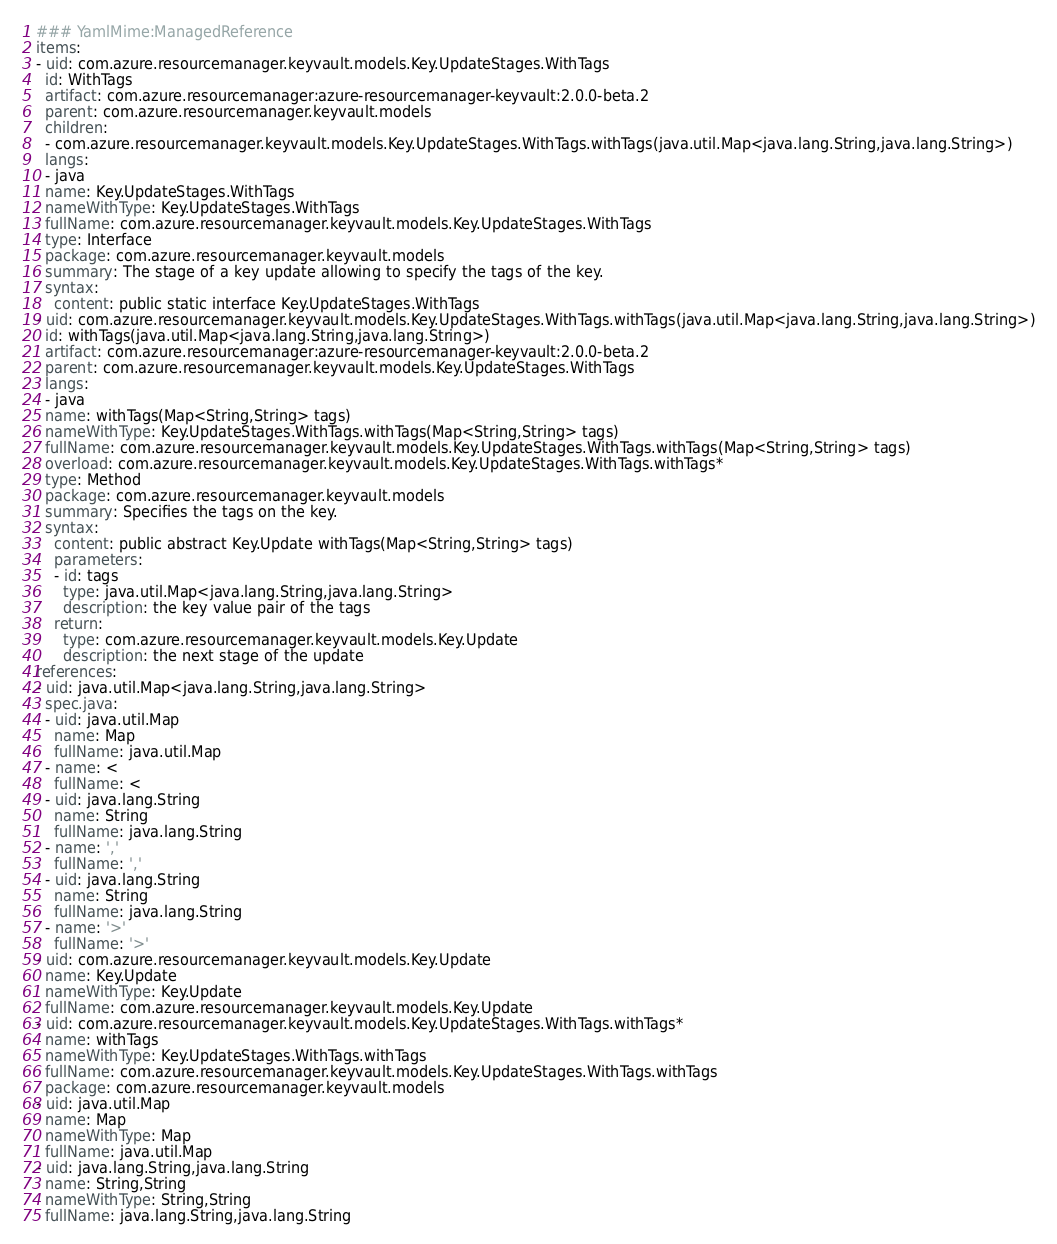Convert code to text. <code><loc_0><loc_0><loc_500><loc_500><_YAML_>### YamlMime:ManagedReference
items:
- uid: com.azure.resourcemanager.keyvault.models.Key.UpdateStages.WithTags
  id: WithTags
  artifact: com.azure.resourcemanager:azure-resourcemanager-keyvault:2.0.0-beta.2
  parent: com.azure.resourcemanager.keyvault.models
  children:
  - com.azure.resourcemanager.keyvault.models.Key.UpdateStages.WithTags.withTags(java.util.Map<java.lang.String,java.lang.String>)
  langs:
  - java
  name: Key.UpdateStages.WithTags
  nameWithType: Key.UpdateStages.WithTags
  fullName: com.azure.resourcemanager.keyvault.models.Key.UpdateStages.WithTags
  type: Interface
  package: com.azure.resourcemanager.keyvault.models
  summary: The stage of a key update allowing to specify the tags of the key.
  syntax:
    content: public static interface Key.UpdateStages.WithTags
- uid: com.azure.resourcemanager.keyvault.models.Key.UpdateStages.WithTags.withTags(java.util.Map<java.lang.String,java.lang.String>)
  id: withTags(java.util.Map<java.lang.String,java.lang.String>)
  artifact: com.azure.resourcemanager:azure-resourcemanager-keyvault:2.0.0-beta.2
  parent: com.azure.resourcemanager.keyvault.models.Key.UpdateStages.WithTags
  langs:
  - java
  name: withTags(Map<String,String> tags)
  nameWithType: Key.UpdateStages.WithTags.withTags(Map<String,String> tags)
  fullName: com.azure.resourcemanager.keyvault.models.Key.UpdateStages.WithTags.withTags(Map<String,String> tags)
  overload: com.azure.resourcemanager.keyvault.models.Key.UpdateStages.WithTags.withTags*
  type: Method
  package: com.azure.resourcemanager.keyvault.models
  summary: Specifies the tags on the key.
  syntax:
    content: public abstract Key.Update withTags(Map<String,String> tags)
    parameters:
    - id: tags
      type: java.util.Map<java.lang.String,java.lang.String>
      description: the key value pair of the tags
    return:
      type: com.azure.resourcemanager.keyvault.models.Key.Update
      description: the next stage of the update
references:
- uid: java.util.Map<java.lang.String,java.lang.String>
  spec.java:
  - uid: java.util.Map
    name: Map
    fullName: java.util.Map
  - name: <
    fullName: <
  - uid: java.lang.String
    name: String
    fullName: java.lang.String
  - name: ','
    fullName: ','
  - uid: java.lang.String
    name: String
    fullName: java.lang.String
  - name: '>'
    fullName: '>'
- uid: com.azure.resourcemanager.keyvault.models.Key.Update
  name: Key.Update
  nameWithType: Key.Update
  fullName: com.azure.resourcemanager.keyvault.models.Key.Update
- uid: com.azure.resourcemanager.keyvault.models.Key.UpdateStages.WithTags.withTags*
  name: withTags
  nameWithType: Key.UpdateStages.WithTags.withTags
  fullName: com.azure.resourcemanager.keyvault.models.Key.UpdateStages.WithTags.withTags
  package: com.azure.resourcemanager.keyvault.models
- uid: java.util.Map
  name: Map
  nameWithType: Map
  fullName: java.util.Map
- uid: java.lang.String,java.lang.String
  name: String,String
  nameWithType: String,String
  fullName: java.lang.String,java.lang.String
</code> 